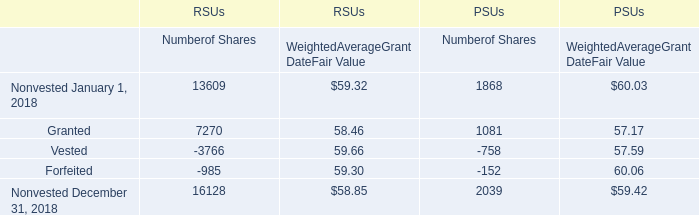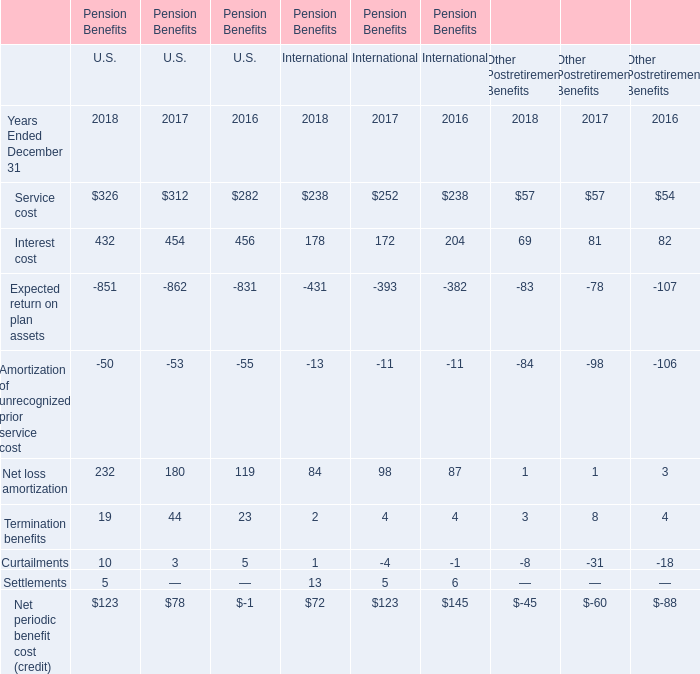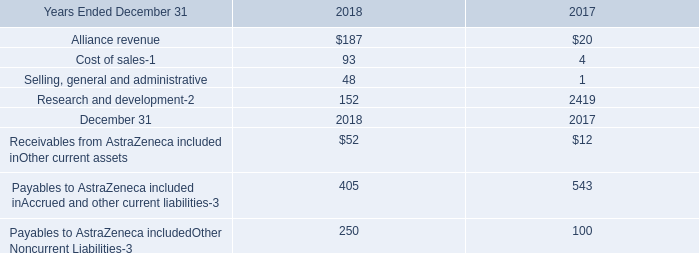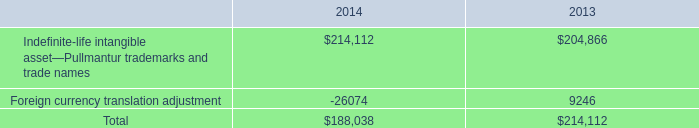what was the percentage increase in the intangible assets are reported in other assets from 2013 to 2014 
Computations: ((214112 / 204866) / 204866)
Answer: 1e-05. 